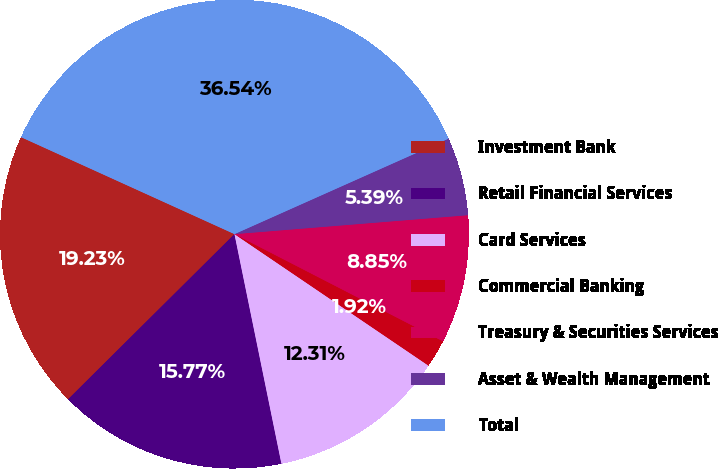<chart> <loc_0><loc_0><loc_500><loc_500><pie_chart><fcel>Investment Bank<fcel>Retail Financial Services<fcel>Card Services<fcel>Commercial Banking<fcel>Treasury & Securities Services<fcel>Asset & Wealth Management<fcel>Total<nl><fcel>19.23%<fcel>15.77%<fcel>12.31%<fcel>1.92%<fcel>8.85%<fcel>5.39%<fcel>36.54%<nl></chart> 